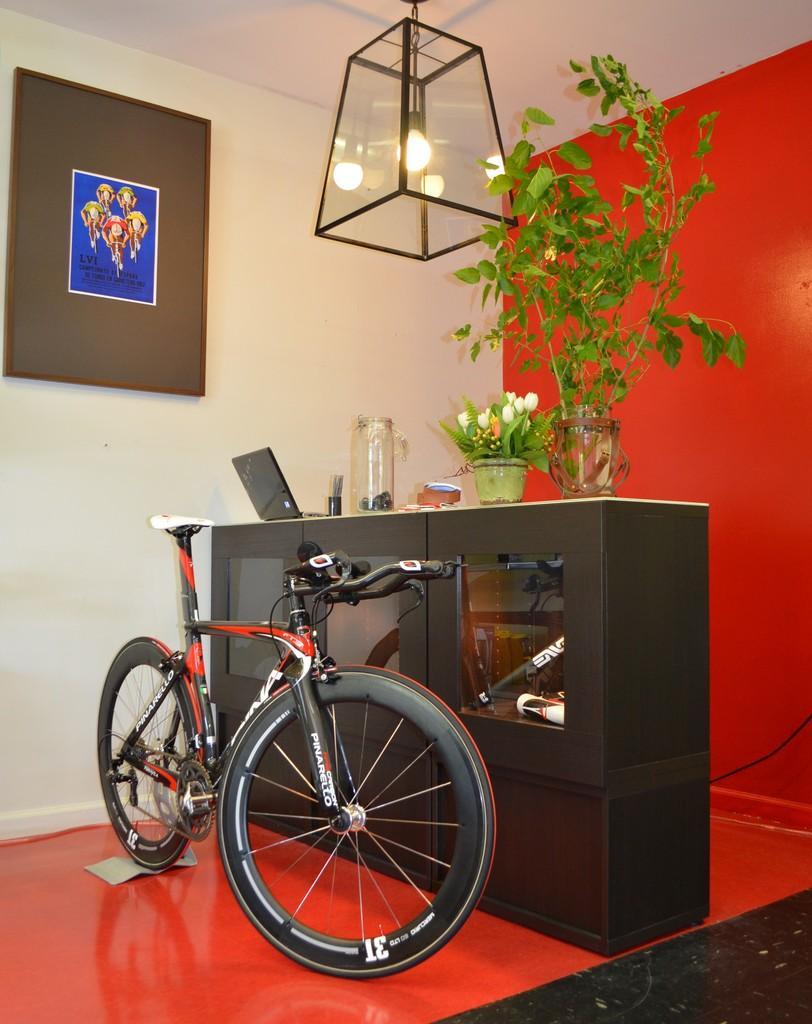In one or two sentences, can you explain what this image depicts? In the image we can see there is a bicycle parked on the ground, there are flowers and plants kept in the vase. There is a laptop and there is jar kept on the table. There is a photo frame kept on the wall and there is light on the top. 